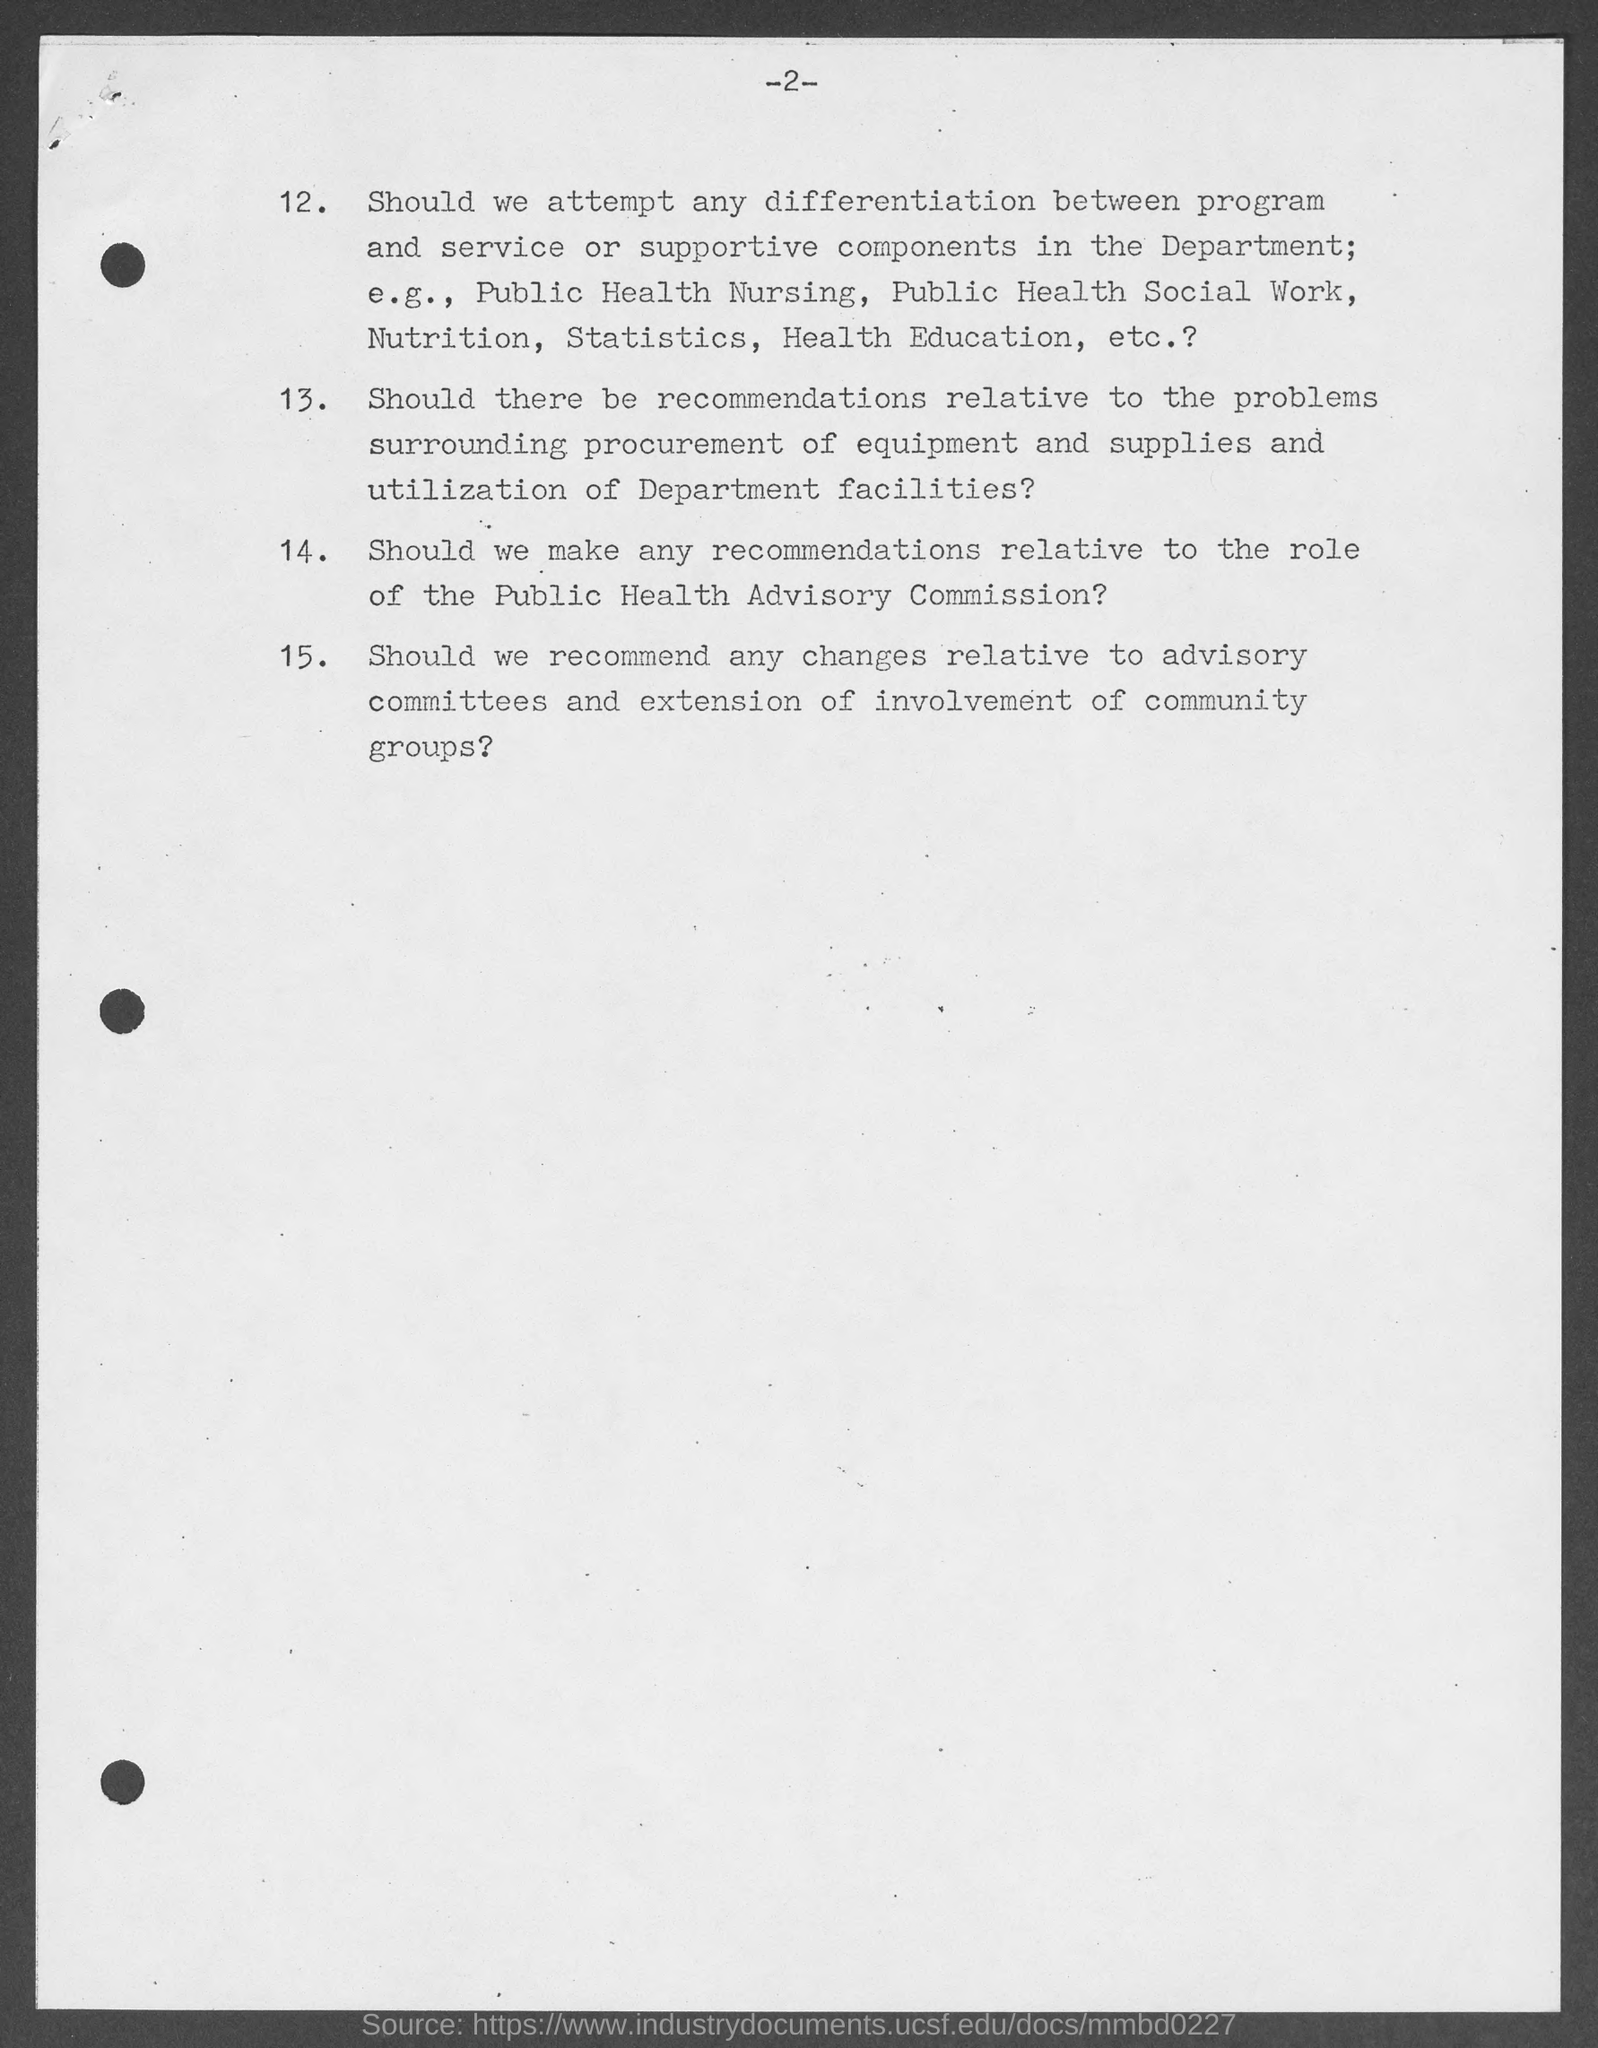What is the page no mentioned in this document?
Make the answer very short. 2. 